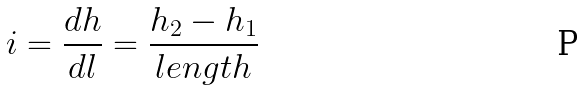<formula> <loc_0><loc_0><loc_500><loc_500>i = \frac { d h } { d l } = \frac { h _ { 2 } - h _ { 1 } } { l e n g t h }</formula> 